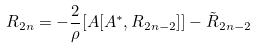Convert formula to latex. <formula><loc_0><loc_0><loc_500><loc_500>R _ { 2 n } = - \frac { 2 } { \rho } [ A [ A ^ { * } , R _ { 2 n - 2 } ] ] - \tilde { R } _ { 2 n - 2 }</formula> 